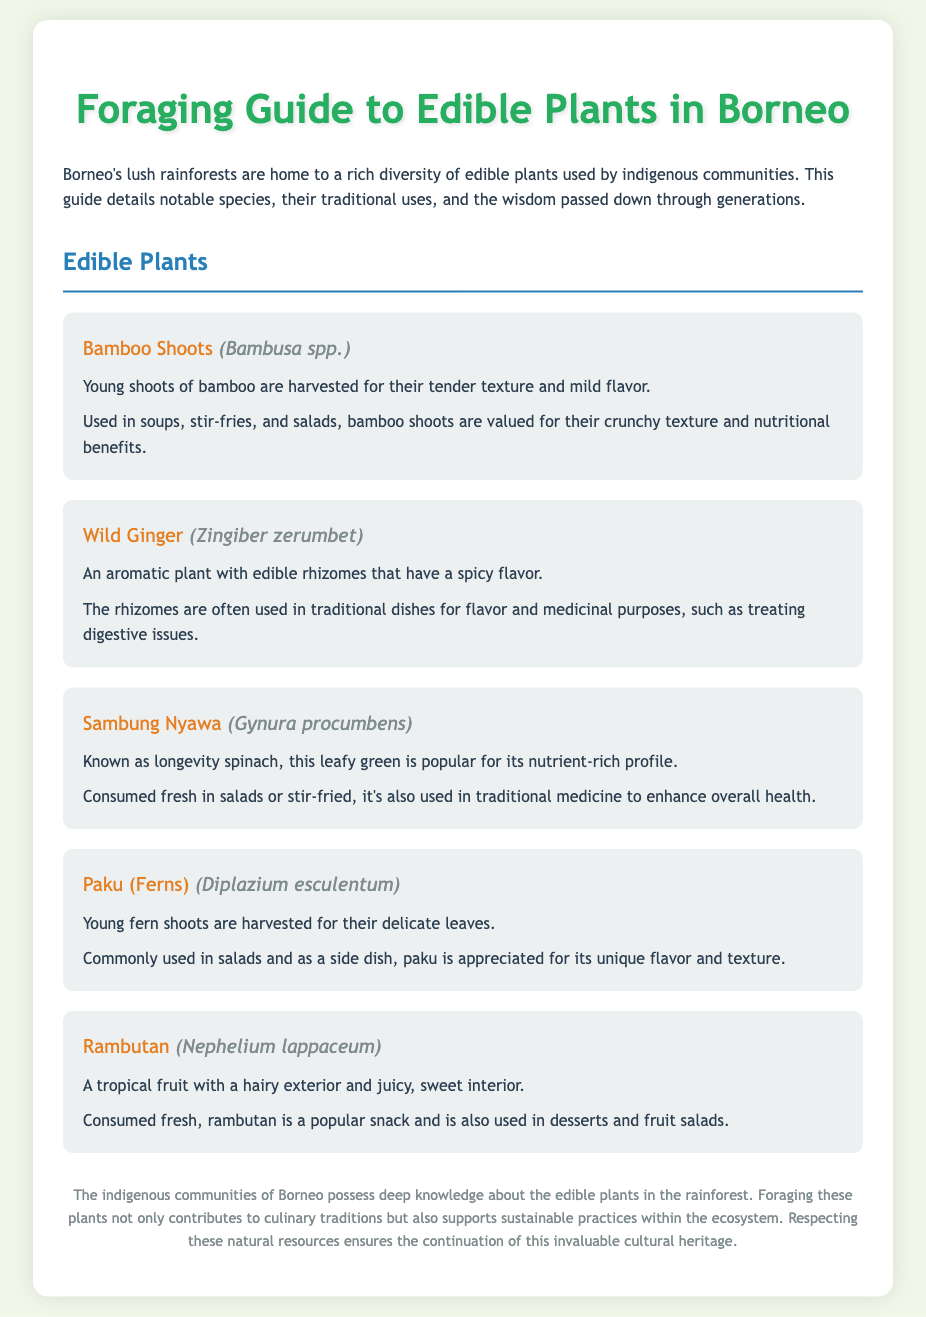what is the title of the document? The title of the document is stated in the header section, which reads "Foraging Guide to Edible Plants in Borneo."
Answer: Foraging Guide to Edible Plants in Borneo how many edible plants are listed in the document? The document mentions five edible plants in the "Edible Plants" section.
Answer: 5 what is the scientific name of Bamboo Shoots? The scientific name is provided next to the common name of Bamboo Shoots in the document.
Answer: Bambusa spp what traditional use is associated with Wild Ginger? The document describes Wild Ginger's use for flavor and medicinal purposes, such as treating digestive issues.
Answer: Treating digestive issues which plant is known as longevity spinach? The document states that Sambung Nyawa is referred to as longevity spinach.
Answer: Sambung Nyawa what is a common dish made with Paku? The document notes that Paku is commonly used in salads and as a side dish.
Answer: Salads what color is the background of the document? The document's style section indicates that the background color is light greenish.
Answer: #f0f7e9 what is the footer's main message? The footer summarizes the importance of indigenous knowledge and sustainable practices regarding foraging in Borneo.
Answer: Sustainable practices within the ecosystem 